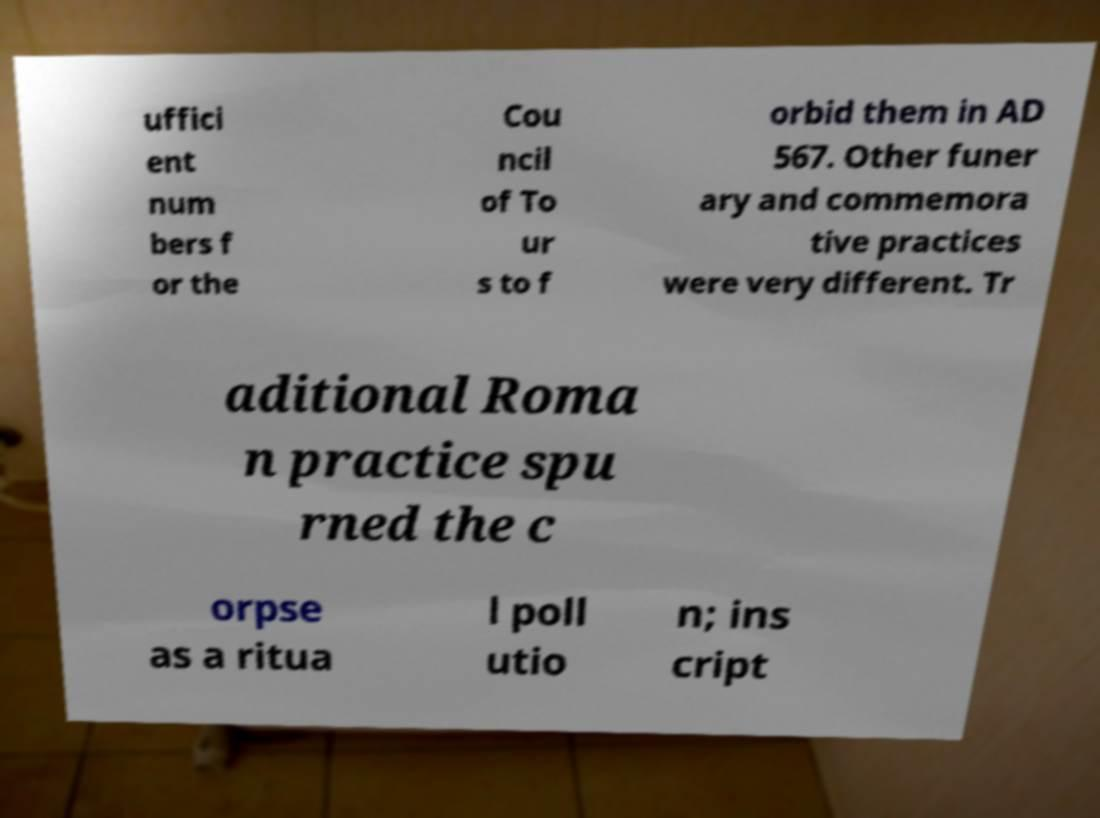Can you read and provide the text displayed in the image?This photo seems to have some interesting text. Can you extract and type it out for me? uffici ent num bers f or the Cou ncil of To ur s to f orbid them in AD 567. Other funer ary and commemora tive practices were very different. Tr aditional Roma n practice spu rned the c orpse as a ritua l poll utio n; ins cript 